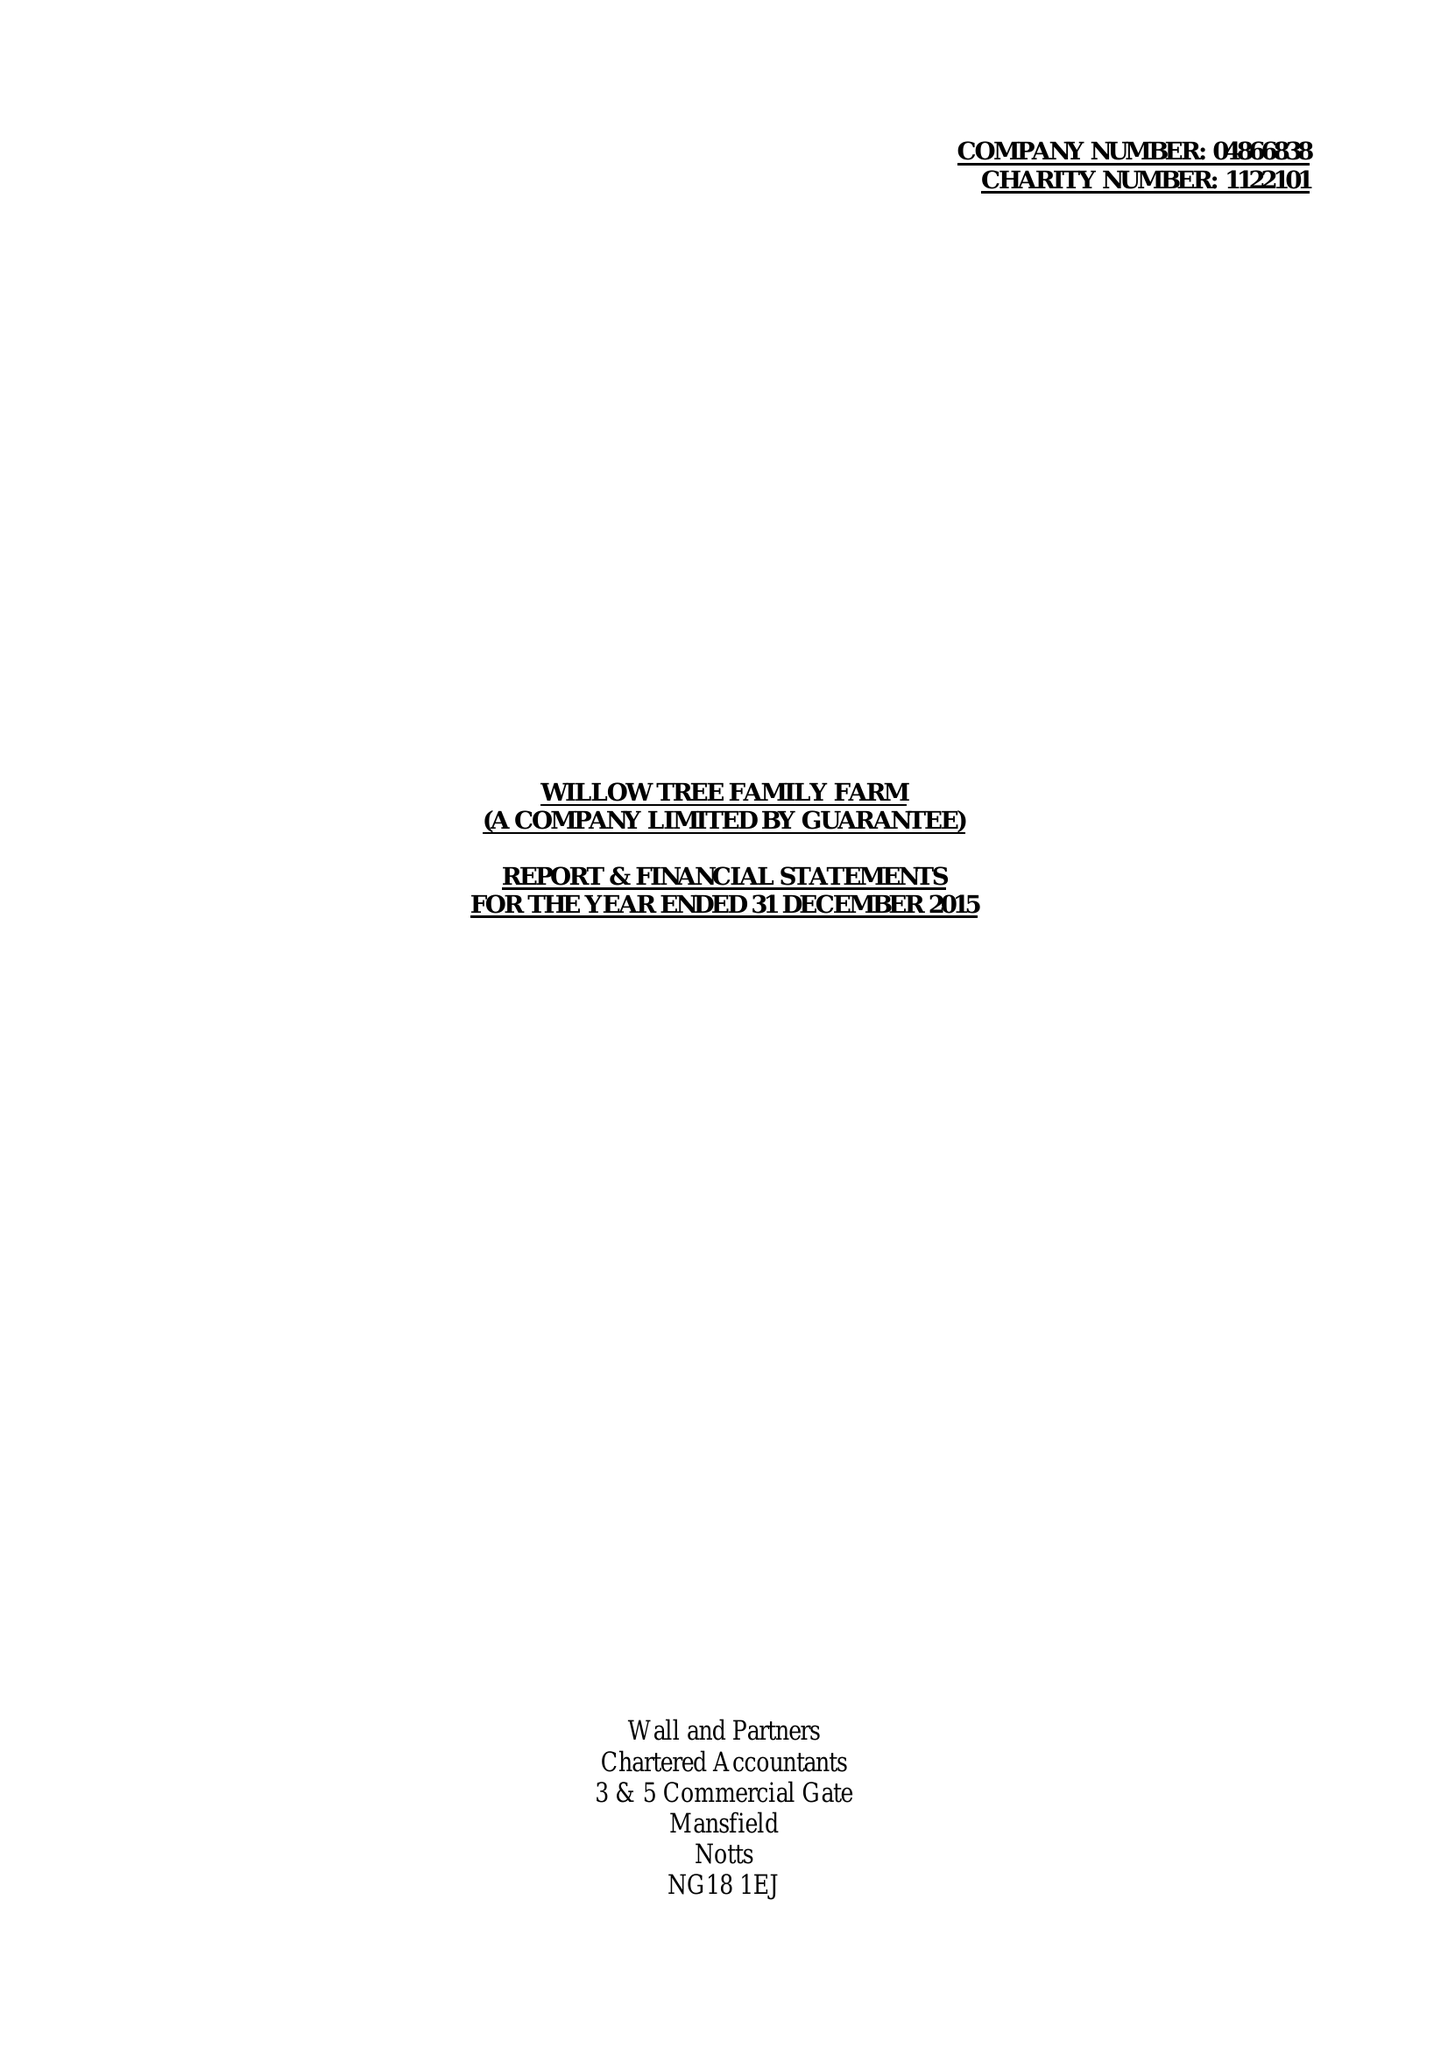What is the value for the address__postcode?
Answer the question using a single word or phrase. NG20 8TF 